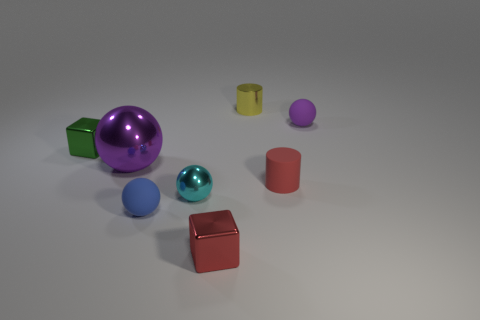Subtract all tiny spheres. How many spheres are left? 1 Subtract all cyan spheres. How many spheres are left? 3 Subtract all green spheres. Subtract all red cubes. How many spheres are left? 4 Add 1 red cylinders. How many objects exist? 9 Subtract 1 red blocks. How many objects are left? 7 Subtract all cylinders. How many objects are left? 6 Subtract all tiny yellow metallic objects. Subtract all tiny cyan objects. How many objects are left? 6 Add 1 red blocks. How many red blocks are left? 2 Add 5 small purple balls. How many small purple balls exist? 6 